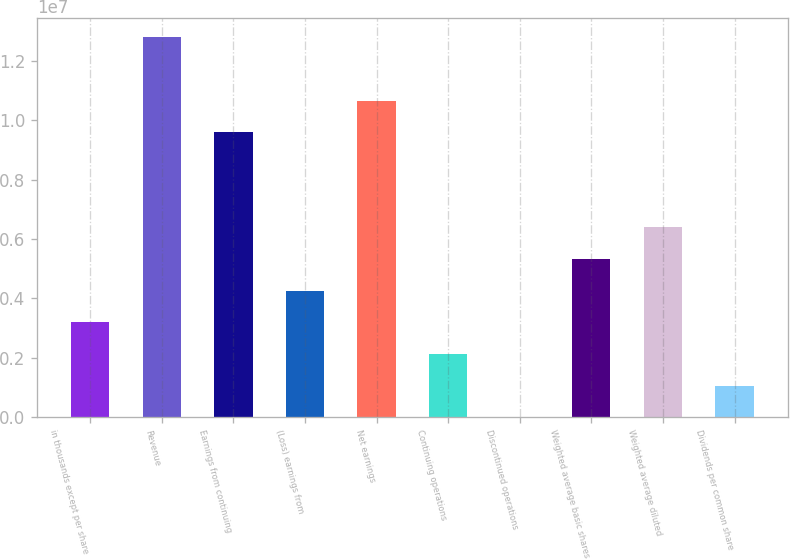<chart> <loc_0><loc_0><loc_500><loc_500><bar_chart><fcel>in thousands except per share<fcel>Revenue<fcel>Earnings from continuing<fcel>(Loss) earnings from<fcel>Net earnings<fcel>Continuing operations<fcel>Discontinued operations<fcel>Weighted average basic shares<fcel>Weighted average diluted<fcel>Dividends per common share<nl><fcel>3.19751e+06<fcel>1.279e+07<fcel>9.59252e+06<fcel>4.26334e+06<fcel>1.06584e+07<fcel>2.13167e+06<fcel>0.42<fcel>5.32918e+06<fcel>6.39502e+06<fcel>1.06584e+06<nl></chart> 